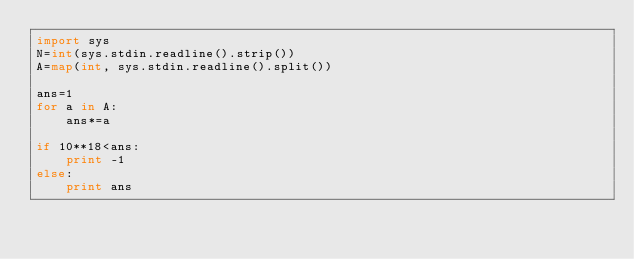Convert code to text. <code><loc_0><loc_0><loc_500><loc_500><_Python_>import sys
N=int(sys.stdin.readline().strip())
A=map(int, sys.stdin.readline().split())

ans=1
for a in A:
    ans*=a

if 10**18<ans:
    print -1
else:
    print ans
</code> 